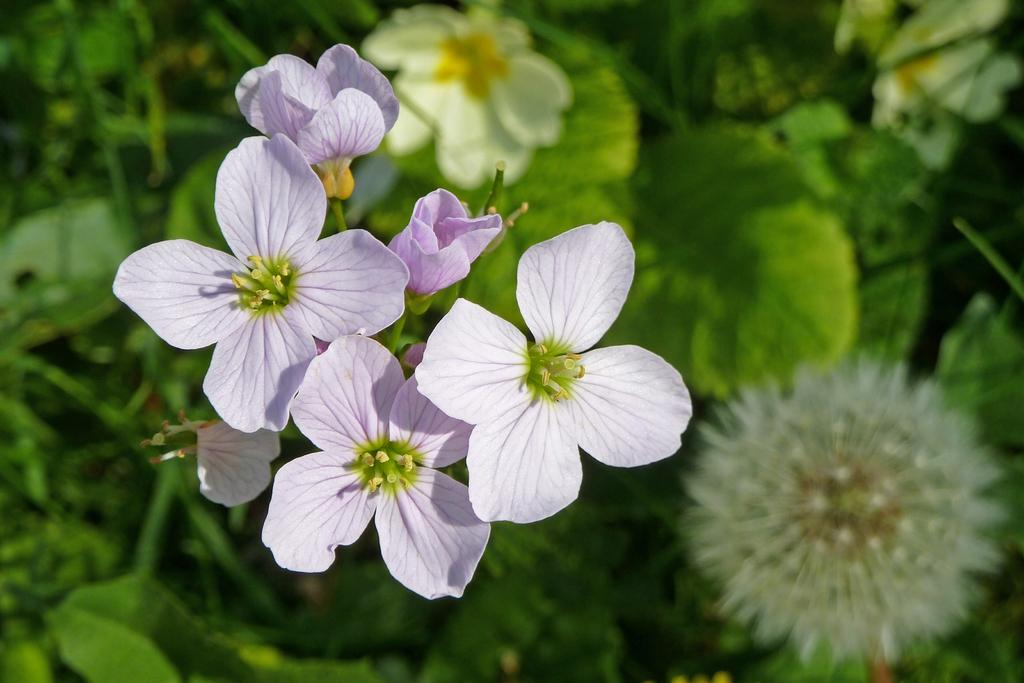What type of living organisms can be seen in the image? There are flowers in the image. Where are the flowers located? The flowers are on plants. What color are the leaves of the plants? The leaves of the plants are green. Can you describe the background of the image? The background of the image is blurred. How many toes can be seen on the maid in the image? There is no maid present in the image, so it is not possible to determine the number of toes visible. 